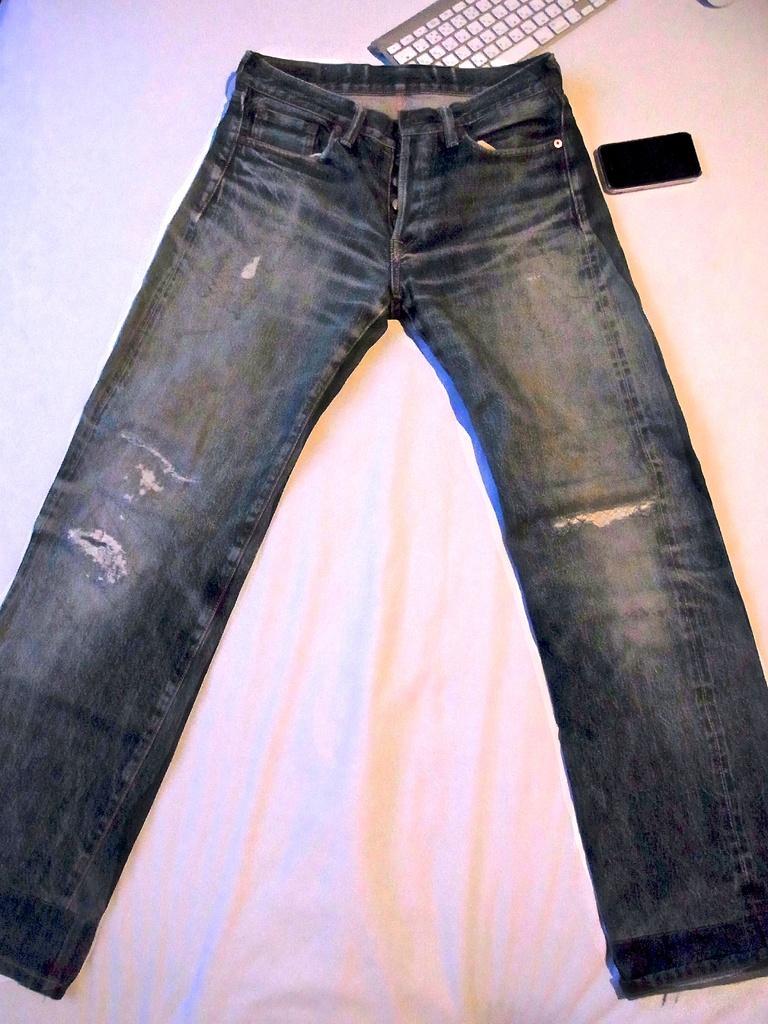Can you describe this image briefly? As we can see in the image there is a bed. On bed there is white color bed sheet, black color jeans, keyboard and mobile phone. 